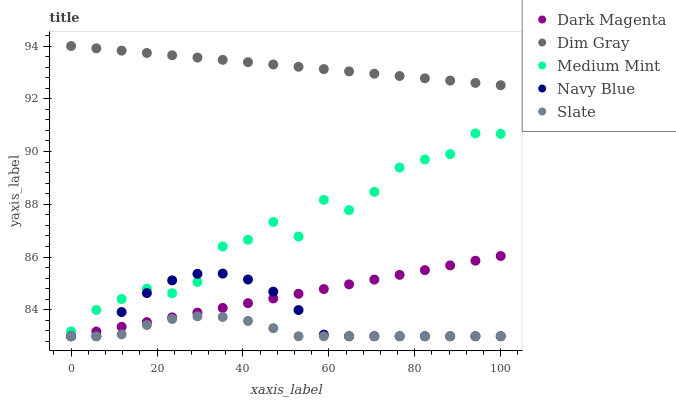Does Slate have the minimum area under the curve?
Answer yes or no. Yes. Does Dim Gray have the maximum area under the curve?
Answer yes or no. Yes. Does Navy Blue have the minimum area under the curve?
Answer yes or no. No. Does Navy Blue have the maximum area under the curve?
Answer yes or no. No. Is Dim Gray the smoothest?
Answer yes or no. Yes. Is Medium Mint the roughest?
Answer yes or no. Yes. Is Navy Blue the smoothest?
Answer yes or no. No. Is Navy Blue the roughest?
Answer yes or no. No. Does Navy Blue have the lowest value?
Answer yes or no. Yes. Does Dim Gray have the lowest value?
Answer yes or no. No. Does Dim Gray have the highest value?
Answer yes or no. Yes. Does Navy Blue have the highest value?
Answer yes or no. No. Is Slate less than Medium Mint?
Answer yes or no. Yes. Is Medium Mint greater than Slate?
Answer yes or no. Yes. Does Navy Blue intersect Medium Mint?
Answer yes or no. Yes. Is Navy Blue less than Medium Mint?
Answer yes or no. No. Is Navy Blue greater than Medium Mint?
Answer yes or no. No. Does Slate intersect Medium Mint?
Answer yes or no. No. 